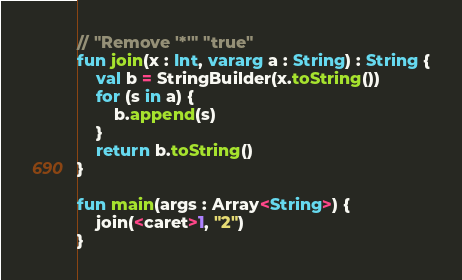<code> <loc_0><loc_0><loc_500><loc_500><_Kotlin_>// "Remove '*'" "true"
fun join(x : Int, vararg a : String) : String {
    val b = StringBuilder(x.toString())
    for (s in a) {
        b.append(s)
    }
    return b.toString()
}

fun main(args : Array<String>) {
    join(<caret>1, "2")
}</code> 